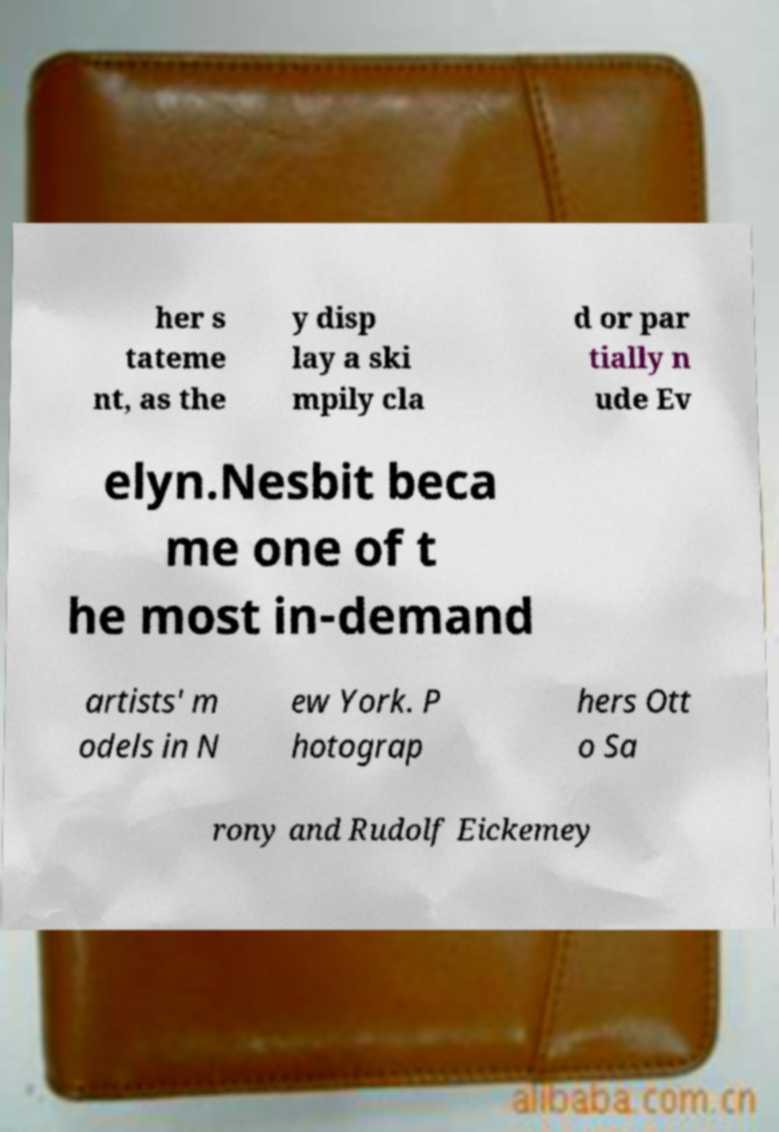Can you read and provide the text displayed in the image?This photo seems to have some interesting text. Can you extract and type it out for me? her s tateme nt, as the y disp lay a ski mpily cla d or par tially n ude Ev elyn.Nesbit beca me one of t he most in-demand artists' m odels in N ew York. P hotograp hers Ott o Sa rony and Rudolf Eickemey 